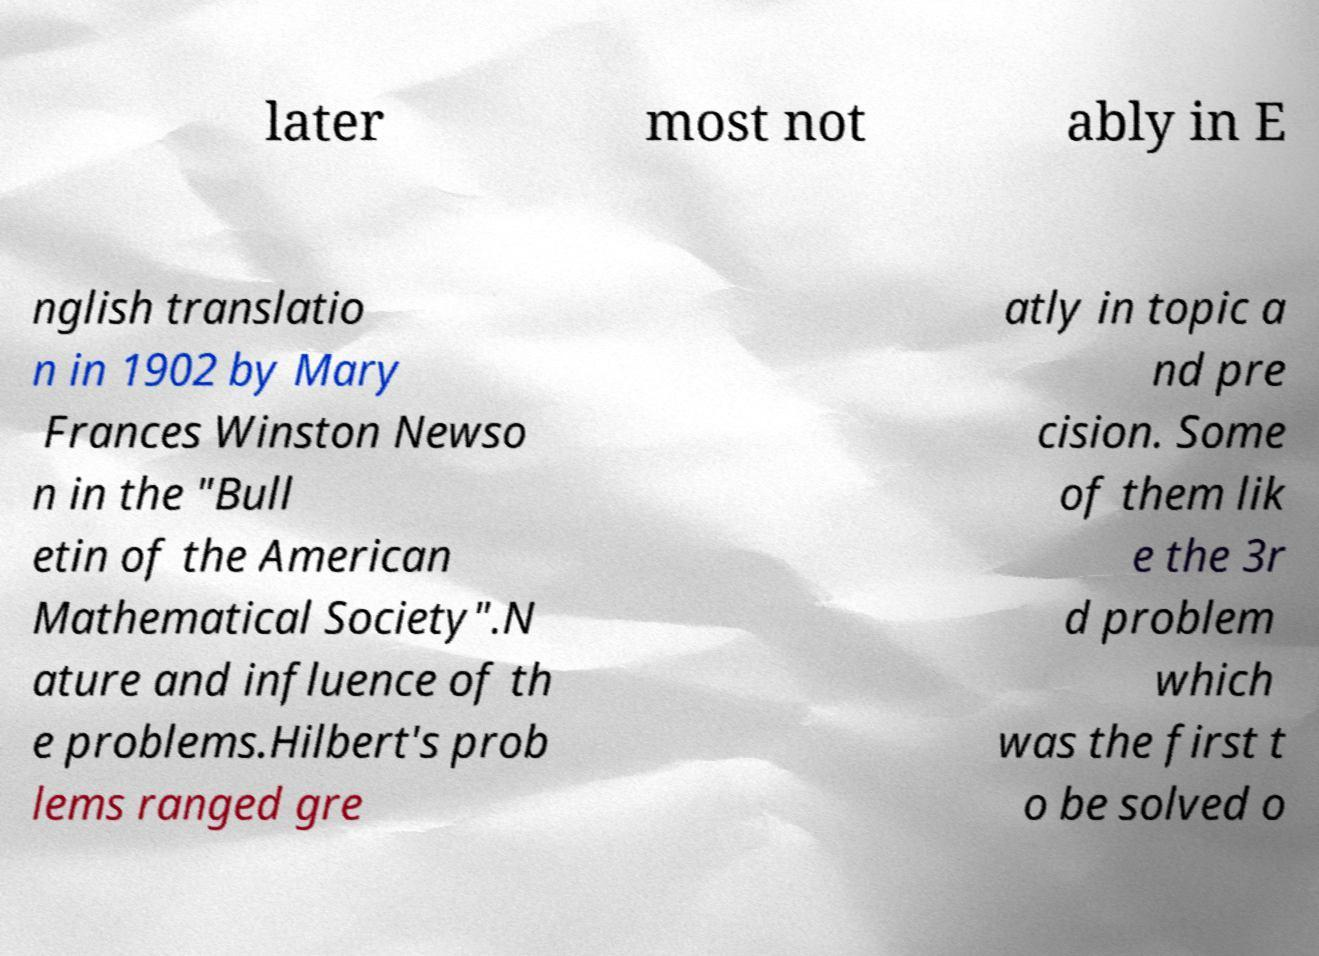There's text embedded in this image that I need extracted. Can you transcribe it verbatim? later most not ably in E nglish translatio n in 1902 by Mary Frances Winston Newso n in the "Bull etin of the American Mathematical Society".N ature and influence of th e problems.Hilbert's prob lems ranged gre atly in topic a nd pre cision. Some of them lik e the 3r d problem which was the first t o be solved o 